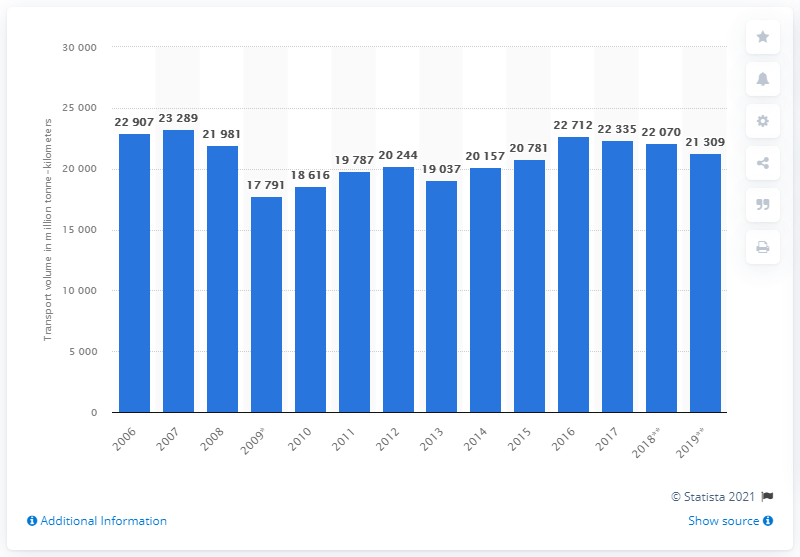Indicate a few pertinent items in this graphic. In 2019, Italy's rail freight transport volume was 21,309. The highest transport volume was achieved in Italy in 2007. 